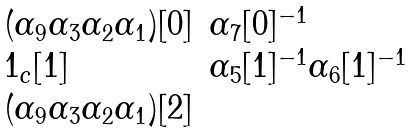Convert formula to latex. <formula><loc_0><loc_0><loc_500><loc_500>\begin{array} { l l } ( \alpha _ { 9 } \alpha _ { 3 } \alpha _ { 2 } \alpha _ { 1 } ) [ 0 ] & \alpha _ { 7 } [ 0 ] ^ { - 1 } \\ 1 _ { c } [ 1 ] & \alpha _ { 5 } [ 1 ] ^ { - 1 } \alpha _ { 6 } [ 1 ] ^ { - 1 } \\ ( \alpha _ { 9 } \alpha _ { 3 } \alpha _ { 2 } \alpha _ { 1 } ) [ 2 ] & \end{array}</formula> 